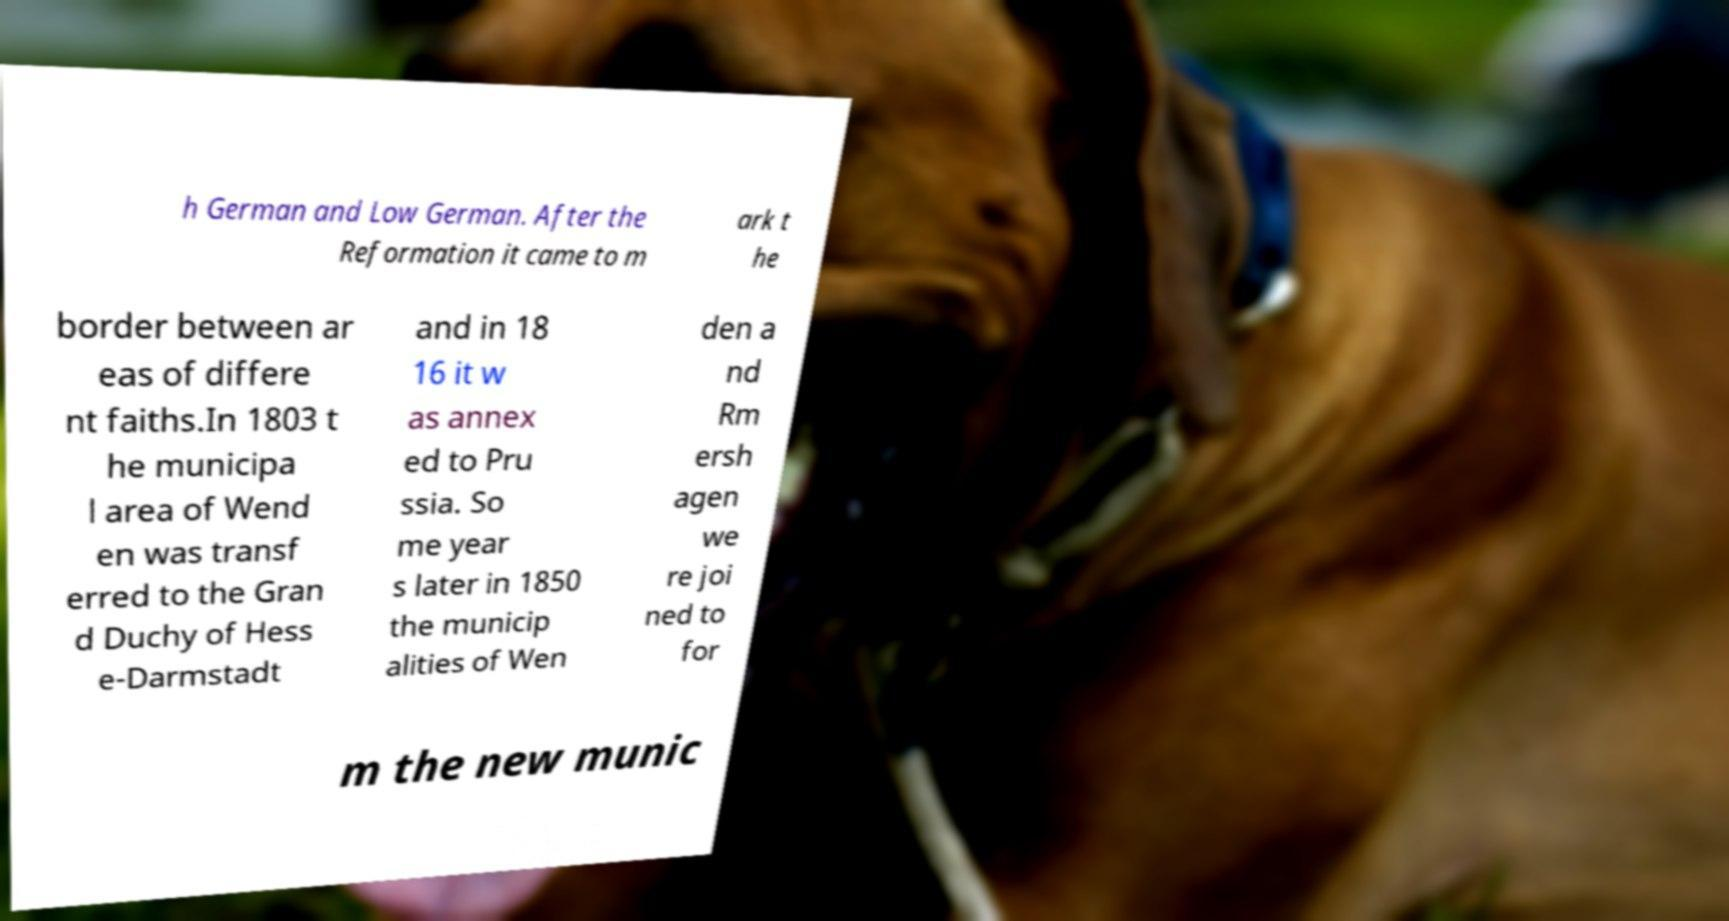I need the written content from this picture converted into text. Can you do that? h German and Low German. After the Reformation it came to m ark t he border between ar eas of differe nt faiths.In 1803 t he municipa l area of Wend en was transf erred to the Gran d Duchy of Hess e-Darmstadt and in 18 16 it w as annex ed to Pru ssia. So me year s later in 1850 the municip alities of Wen den a nd Rm ersh agen we re joi ned to for m the new munic 